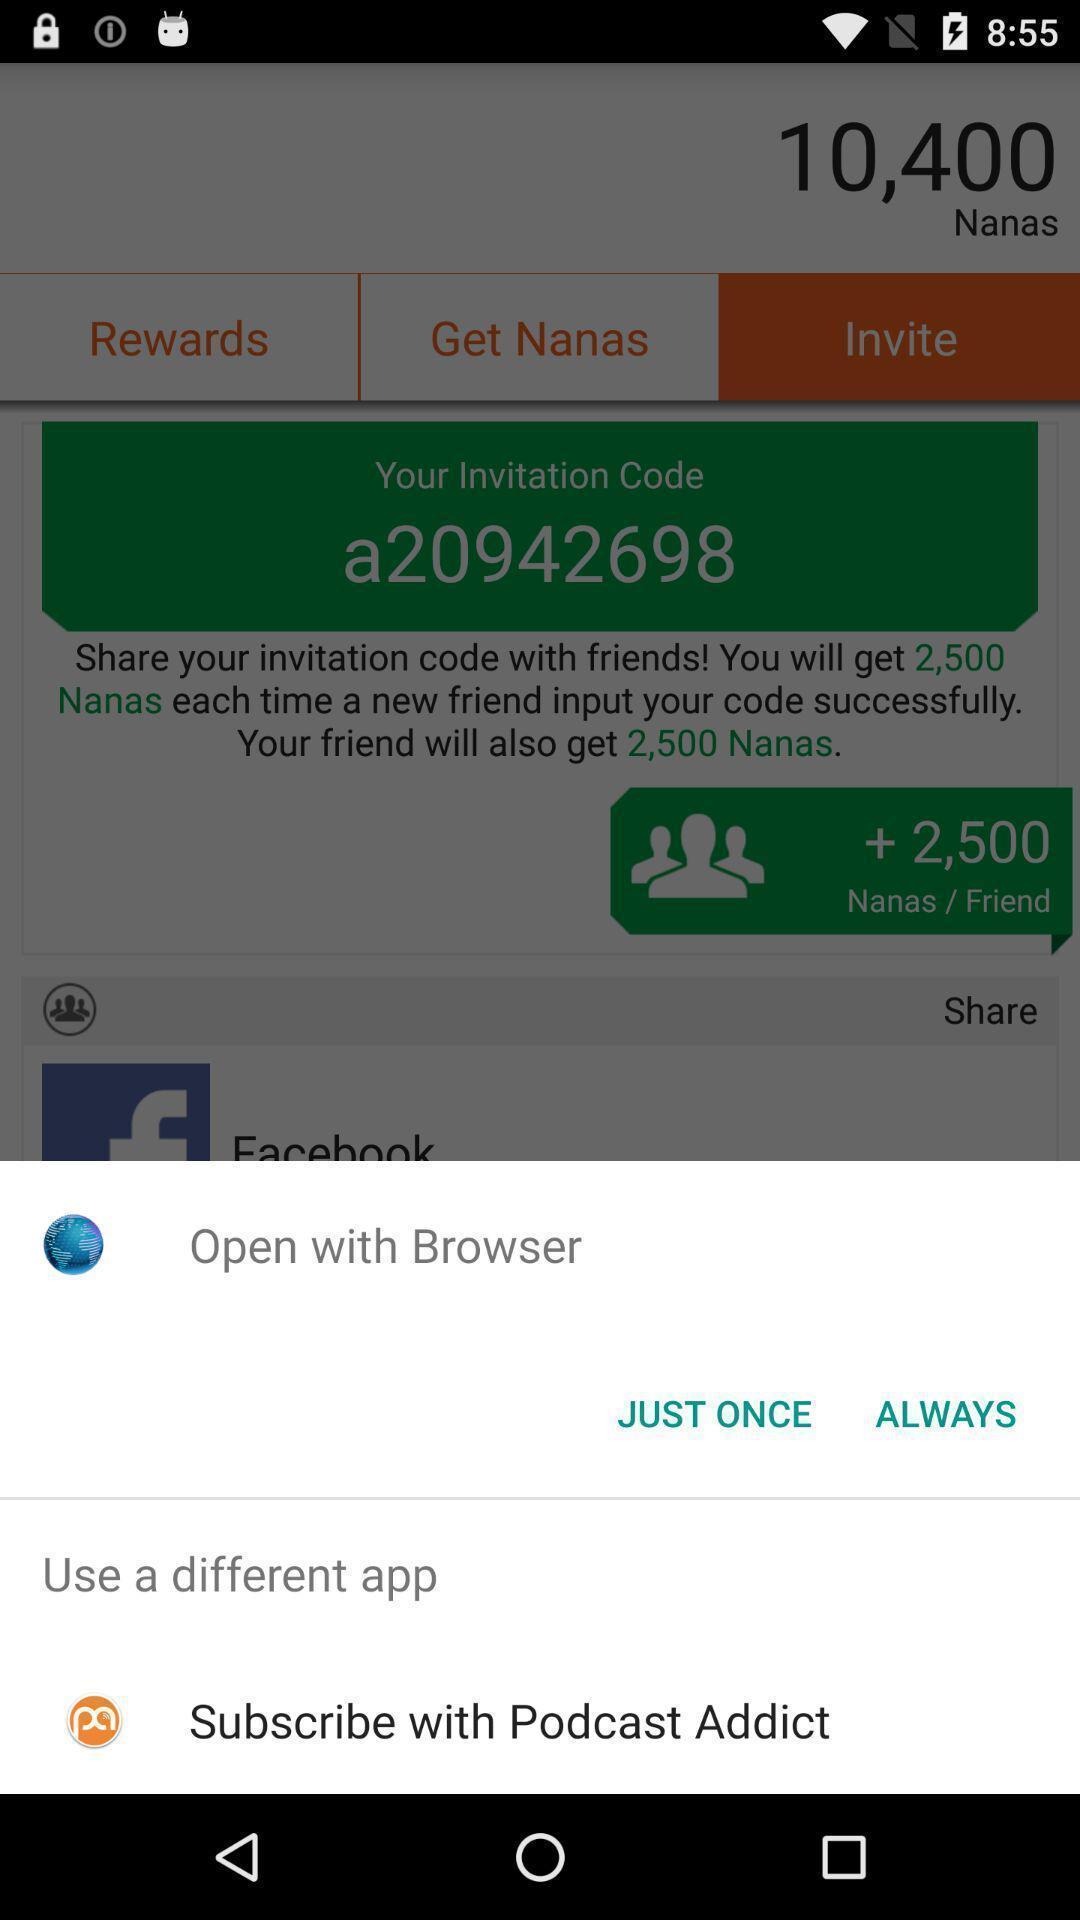Please provide a description for this image. Popup showing different apps options. 